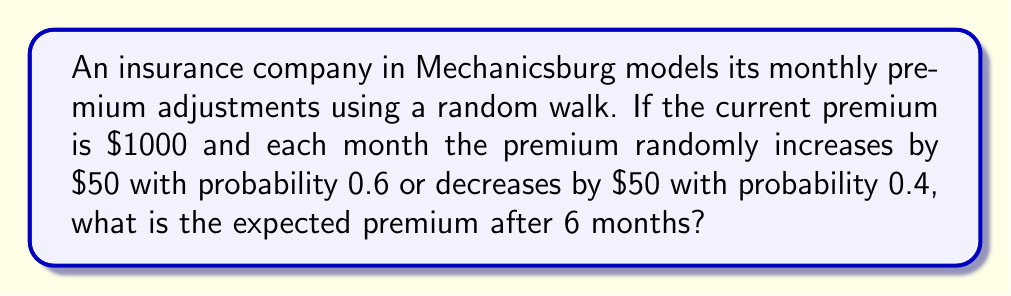Give your solution to this math problem. Let's approach this step-by-step:

1) First, we need to understand the expected change in premium each month:
   
   $E[\text{monthly change}] = 50 \cdot 0.6 + (-50) \cdot 0.4 = 30 + (-20) = 10$

   So, on average, the premium increases by $10 each month.

2) We can model this as a random walk with drift, where the drift is $10 per month.

3) The expected position of a random walk with drift after $n$ steps is given by:

   $E[X_n] = X_0 + n\mu$

   Where $X_0$ is the starting position, $n$ is the number of steps, and $\mu$ is the drift per step.

4) In our case:
   $X_0 = 1000$ (starting premium)
   $n = 6$ (months)
   $\mu = 10$ (expected monthly increase)

5) Plugging these into our formula:

   $E[X_6] = 1000 + 6 \cdot 10 = 1000 + 60 = 1060$

Therefore, the expected premium after 6 months is $1060.
Answer: $1060 